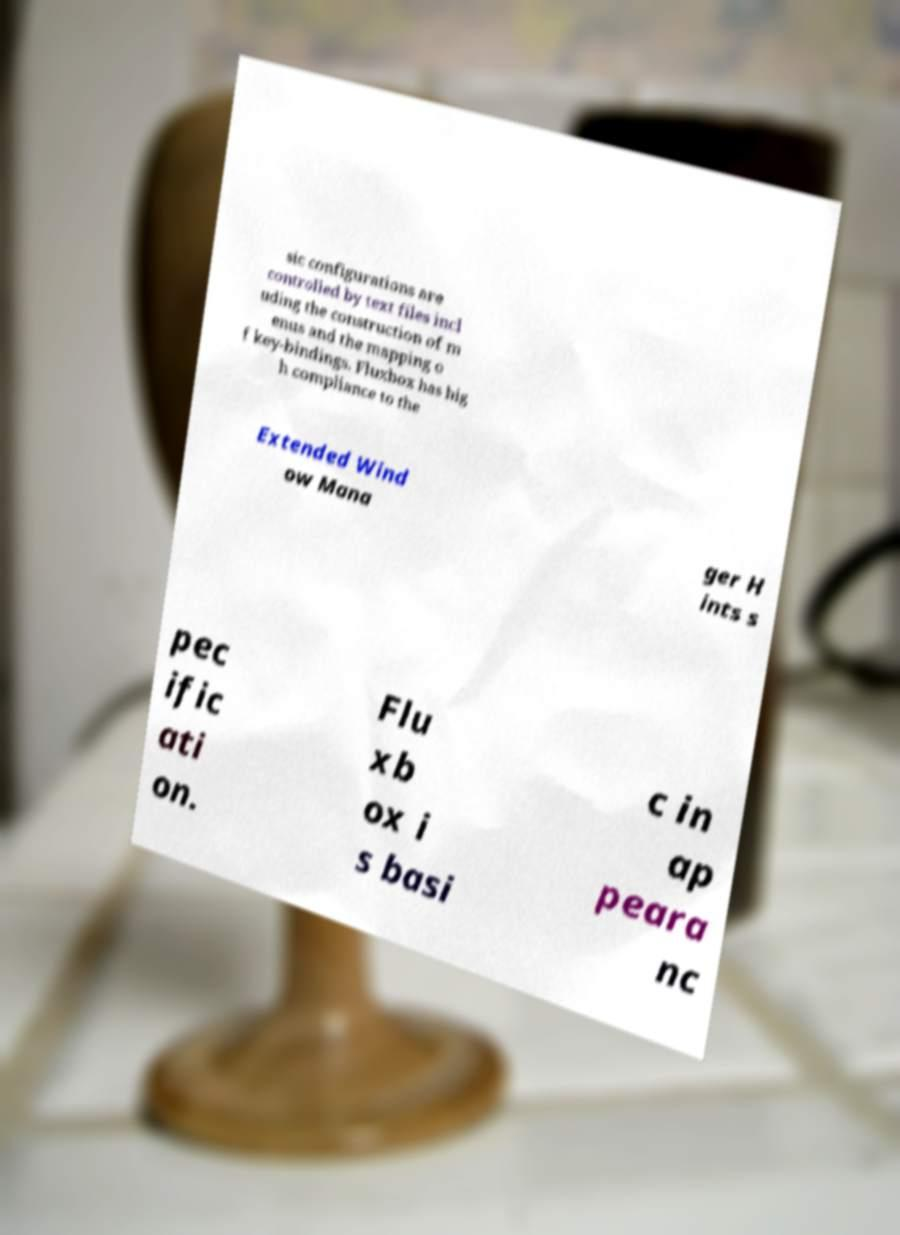Please identify and transcribe the text found in this image. sic configurations are controlled by text files incl uding the construction of m enus and the mapping o f key-bindings. Fluxbox has hig h compliance to the Extended Wind ow Mana ger H ints s pec ific ati on. Flu xb ox i s basi c in ap peara nc 